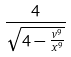Convert formula to latex. <formula><loc_0><loc_0><loc_500><loc_500>\frac { 4 } { \sqrt { 4 - \frac { v ^ { 9 } } { x ^ { 9 } } } }</formula> 